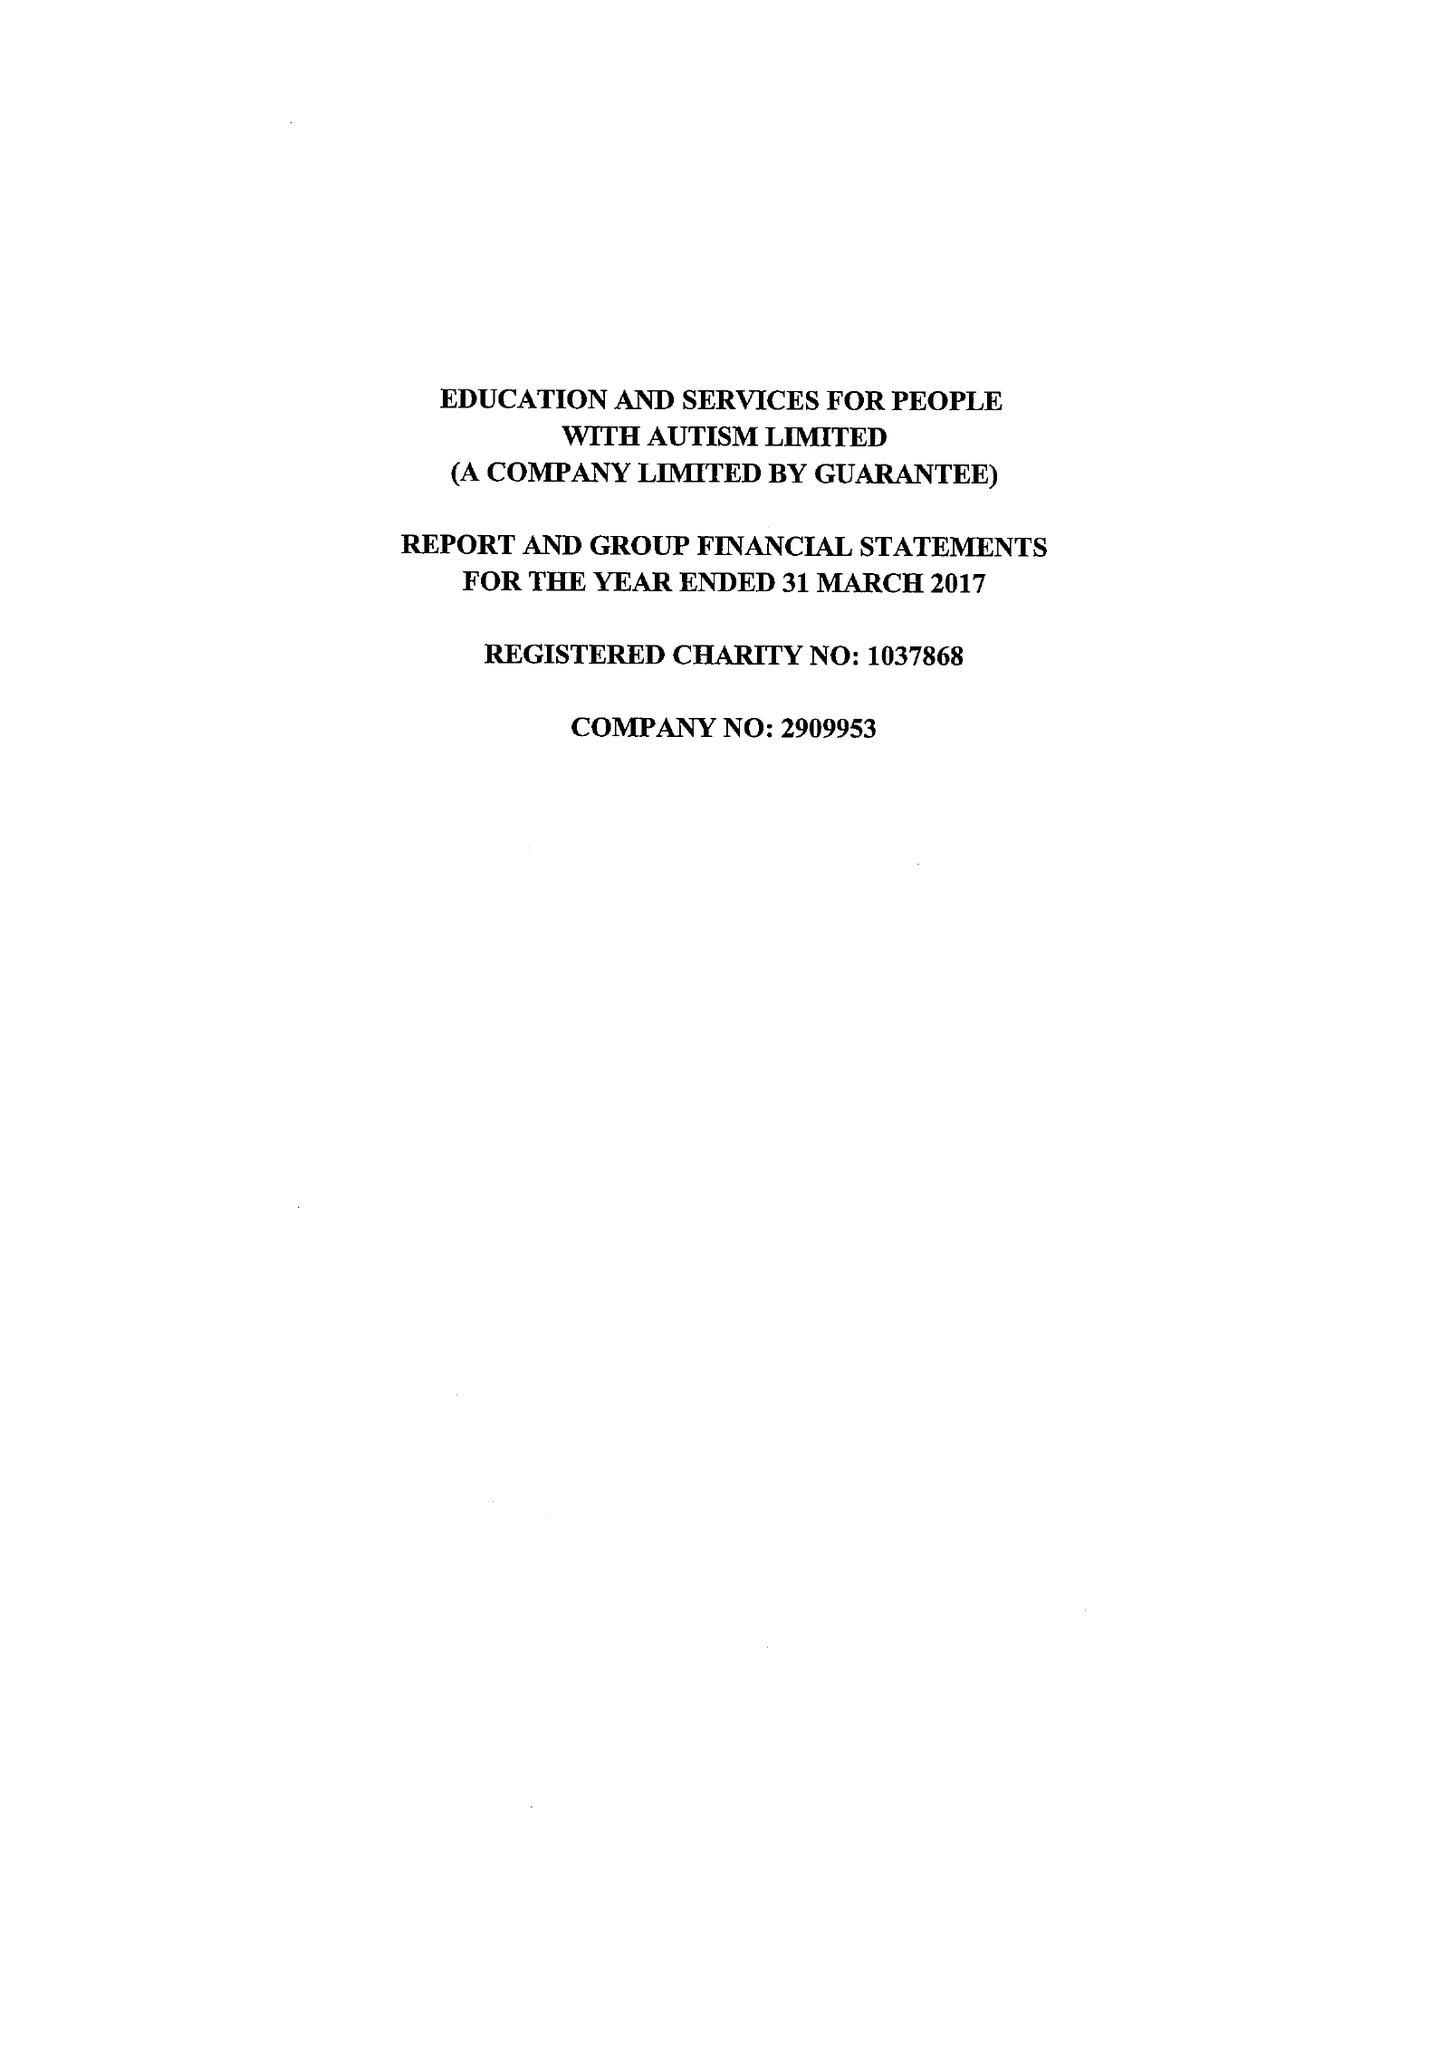What is the value for the address__postcode?
Answer the question using a single word or phrase. SR5 3HD 